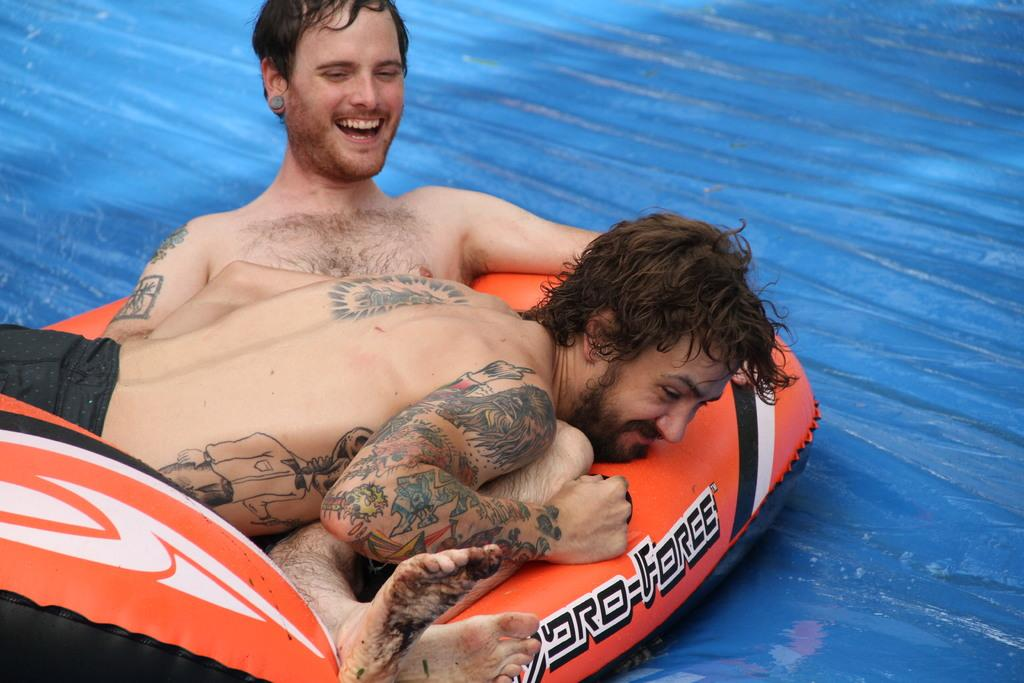What color is the surface that the persons are sliding on in the image? The surface is blue. What are the persons doing on the blue surface? Two persons are sliding on the blue surface. What are the persons using to slide on the blue surface? The persons are using an inflatable tube. tube. Where is the throne located in the image? There is no throne present in the image. What type of veil is draped over the inflatable tube? There is no veil present in the image; the persons are using an inflatable tube to slide on the blue surface. 